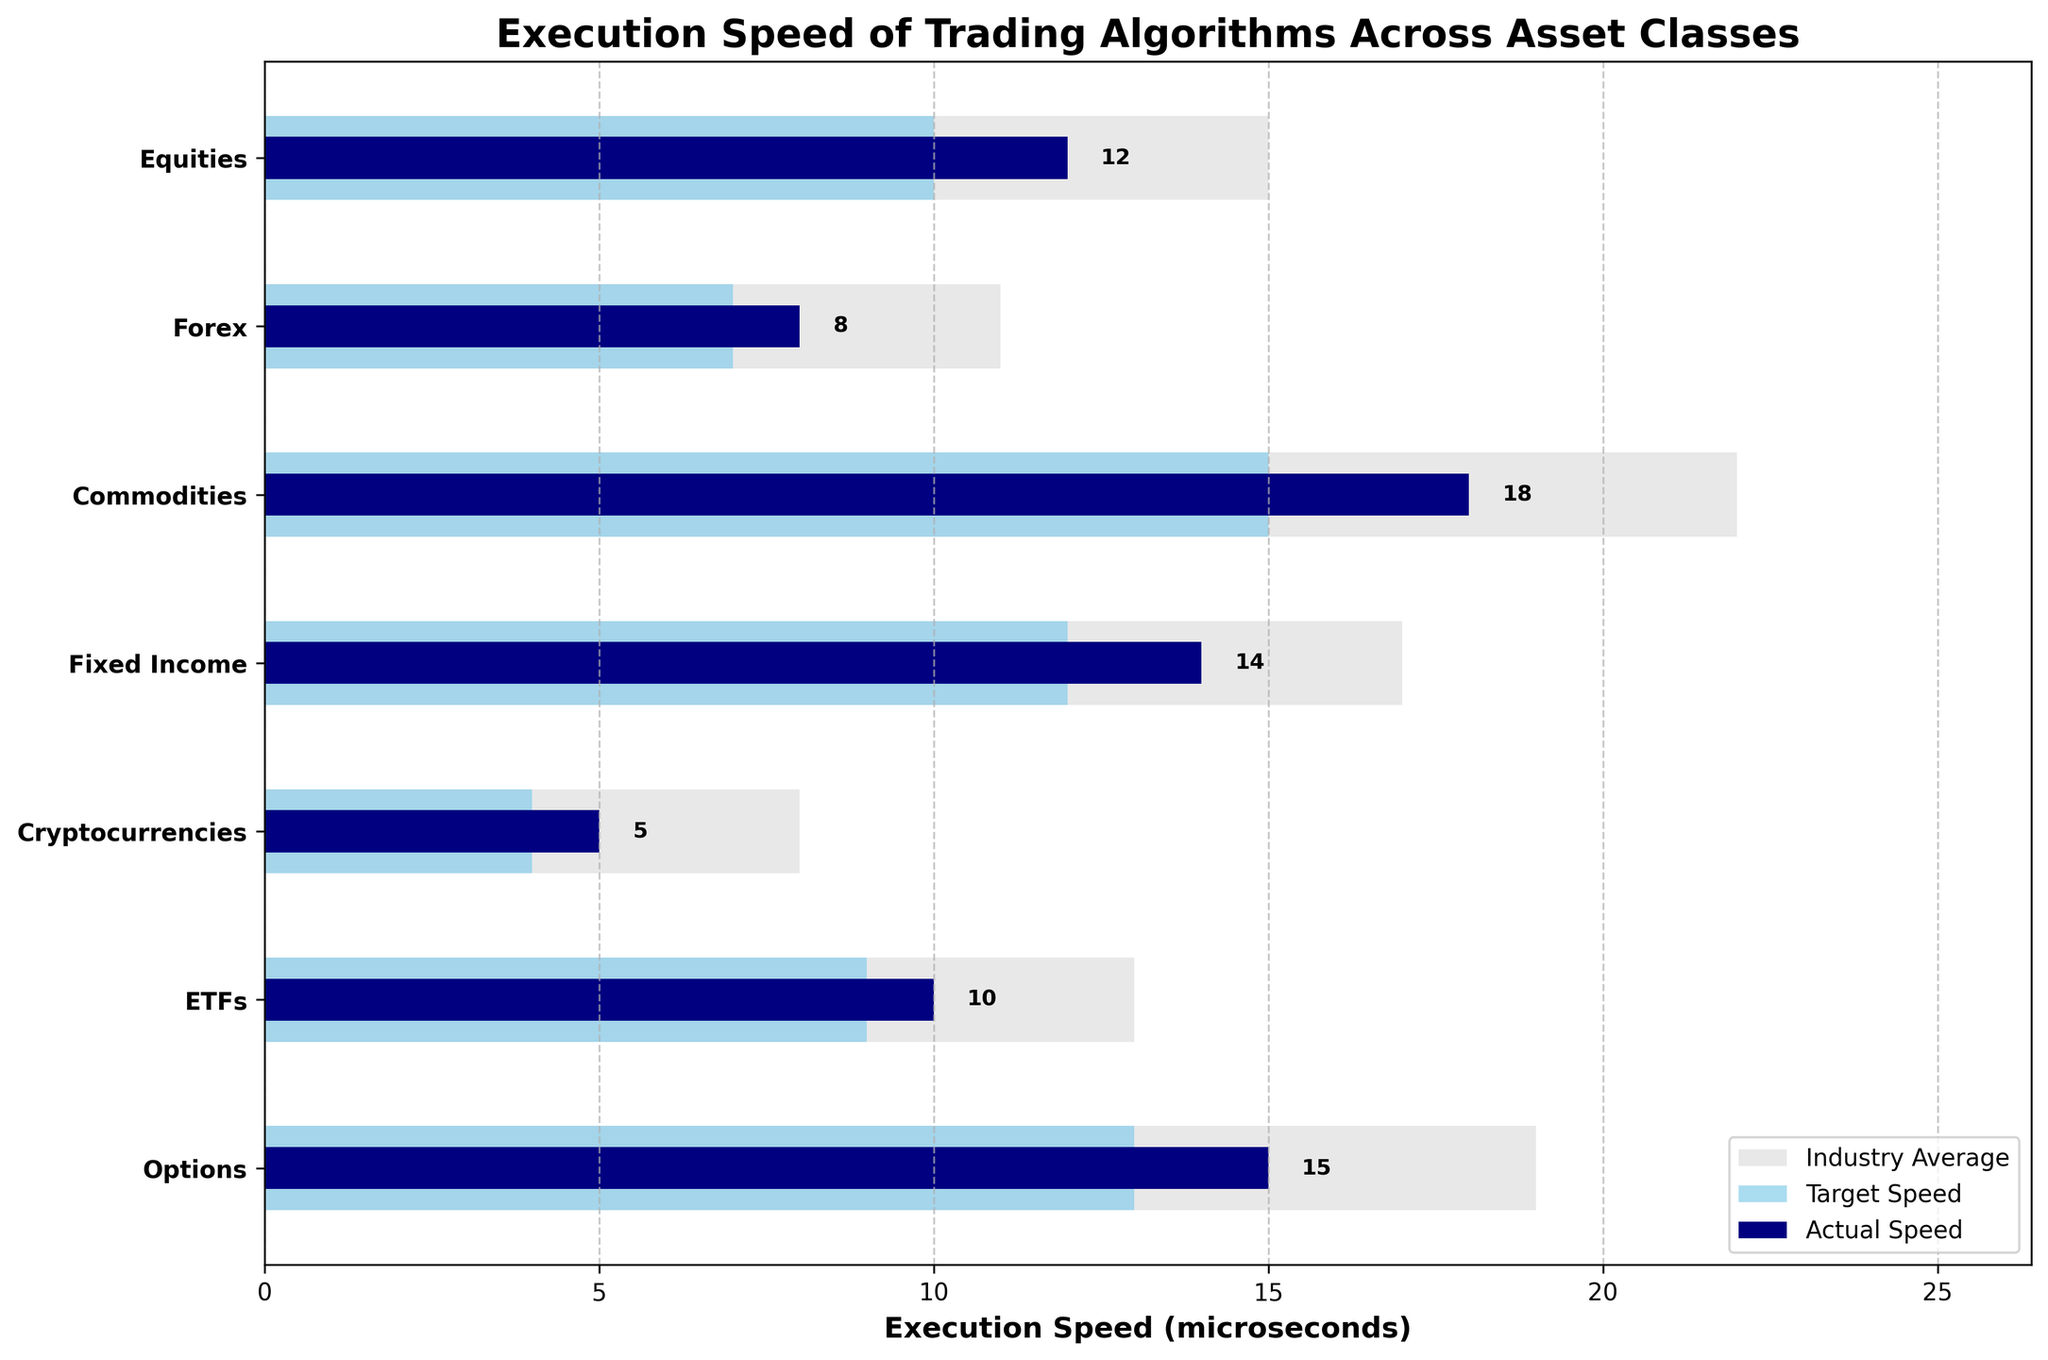What's the title of the figure? The title can be found at the top of the plot, providing an overview of the subject matter. It reads "Execution Speed of Trading Algorithms Across Asset Classes".
Answer: Execution Speed of Trading Algorithms Across Asset Classes What is the x-axis labeled as? The x-axis label can be found below the horizontal axis of the plot. It indicates the unit of measurement, which is "Execution Speed (microseconds)".
Answer: Execution Speed (microseconds) Which asset class has the fastest execution speed? To determine the fastest execution speed, look for the smallest value in the "Actual Speed" bars (dark blue). Cryptocurrencies have the smallest bar value at 5 microseconds.
Answer: Cryptocurrencies How many asset classes are shown in the figure? Count the number of distinct horizontal bars representing the asset classes on the y-axis. There are 7 asset classes represented.
Answer: 7 What is the color used to represent target speed? The legend identifies the target speed color, which is "skyblue" (light blue).
Answer: Light blue For which asset class does the actual speed most closely match the target speed? Compare the dark blue bars (actual speed) with the light blue bars (target speed) for each asset class. Cryptocurrencies have actual speed (5 microseconds) closest to its target speed (4 microseconds).
Answer: Cryptocurrencies Which asset class has the largest discrepancy between its actual and industry average speeds? Calculate the differences between actual speed (dark blue bars) and industry average speed (light grey bars) for each asset class. Commodities have the largest discrepancy (22 - 18 = 4 microseconds).
Answer: Commodities What's the average target speed for all asset classes? Sum up all target speeds: 10 + 7 + 15 + 12 + 4 + 9 + 13 = 70 microseconds. Divide by the number of asset classes, 70 / 7 = 10 microseconds.
Answer: 10 microseconds How does the actual speed for options compare to its target speed? For options, compare the dark blue bar (actual speed) with the light blue bar (target speed). The actual speed is 15 microseconds, and the target speed is 13 microseconds, so the actual speed is 2 microseconds higher.
Answer: 2 microseconds higher What is the industry average speed for Forex? Look at the light grey bar corresponding to Forex; it represents the industry average speed, which is 11 microseconds.
Answer: 11 microseconds For which asset class is the actual speed more than 2 microseconds faster than the target speed? Compare the actual speed (dark blue bars) to the target speed (light blue bars) for each asset class. Equities (12 vs. 10), Commodities (18 vs. 15), Fixed Income (14 vs. 12), and Options (15 vs. 13) meet the criterion.
Answer: Equities, Commodities, Fixed Income, Options 